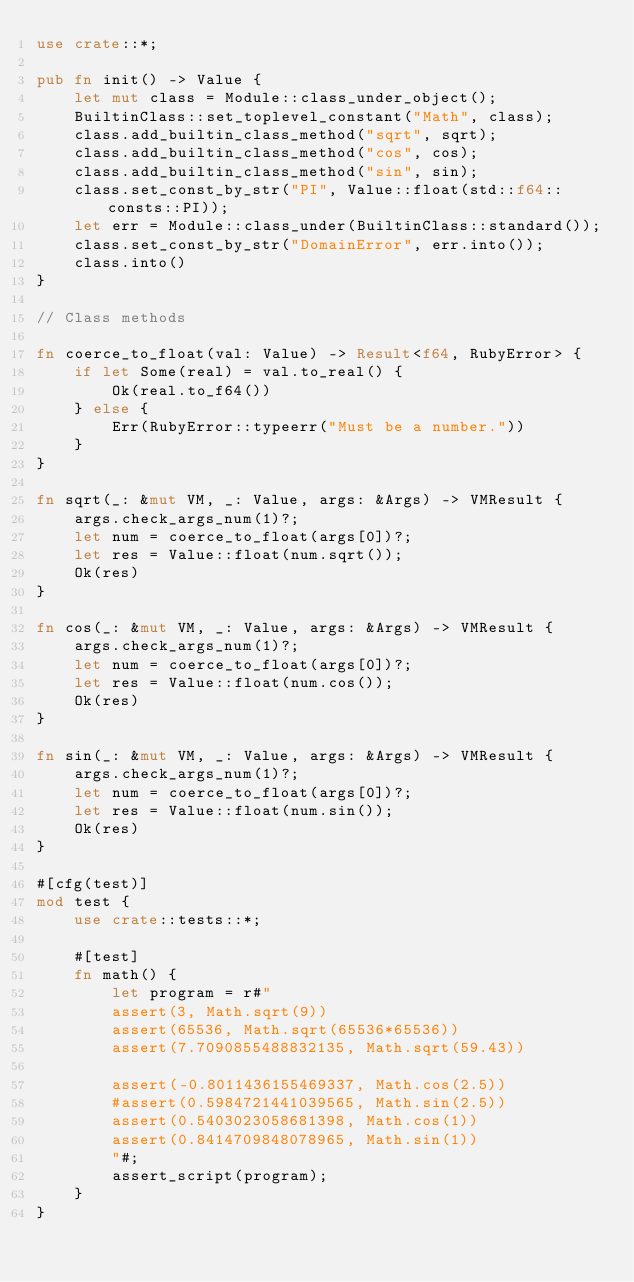<code> <loc_0><loc_0><loc_500><loc_500><_Rust_>use crate::*;

pub fn init() -> Value {
    let mut class = Module::class_under_object();
    BuiltinClass::set_toplevel_constant("Math", class);
    class.add_builtin_class_method("sqrt", sqrt);
    class.add_builtin_class_method("cos", cos);
    class.add_builtin_class_method("sin", sin);
    class.set_const_by_str("PI", Value::float(std::f64::consts::PI));
    let err = Module::class_under(BuiltinClass::standard());
    class.set_const_by_str("DomainError", err.into());
    class.into()
}

// Class methods

fn coerce_to_float(val: Value) -> Result<f64, RubyError> {
    if let Some(real) = val.to_real() {
        Ok(real.to_f64())
    } else {
        Err(RubyError::typeerr("Must be a number."))
    }
}

fn sqrt(_: &mut VM, _: Value, args: &Args) -> VMResult {
    args.check_args_num(1)?;
    let num = coerce_to_float(args[0])?;
    let res = Value::float(num.sqrt());
    Ok(res)
}

fn cos(_: &mut VM, _: Value, args: &Args) -> VMResult {
    args.check_args_num(1)?;
    let num = coerce_to_float(args[0])?;
    let res = Value::float(num.cos());
    Ok(res)
}

fn sin(_: &mut VM, _: Value, args: &Args) -> VMResult {
    args.check_args_num(1)?;
    let num = coerce_to_float(args[0])?;
    let res = Value::float(num.sin());
    Ok(res)
}

#[cfg(test)]
mod test {
    use crate::tests::*;

    #[test]
    fn math() {
        let program = r#"
        assert(3, Math.sqrt(9))
        assert(65536, Math.sqrt(65536*65536))
        assert(7.7090855488832135, Math.sqrt(59.43))

        assert(-0.8011436155469337, Math.cos(2.5))
        #assert(0.5984721441039565, Math.sin(2.5))
        assert(0.5403023058681398, Math.cos(1))
        assert(0.8414709848078965, Math.sin(1))
        "#;
        assert_script(program);
    }
}
</code> 